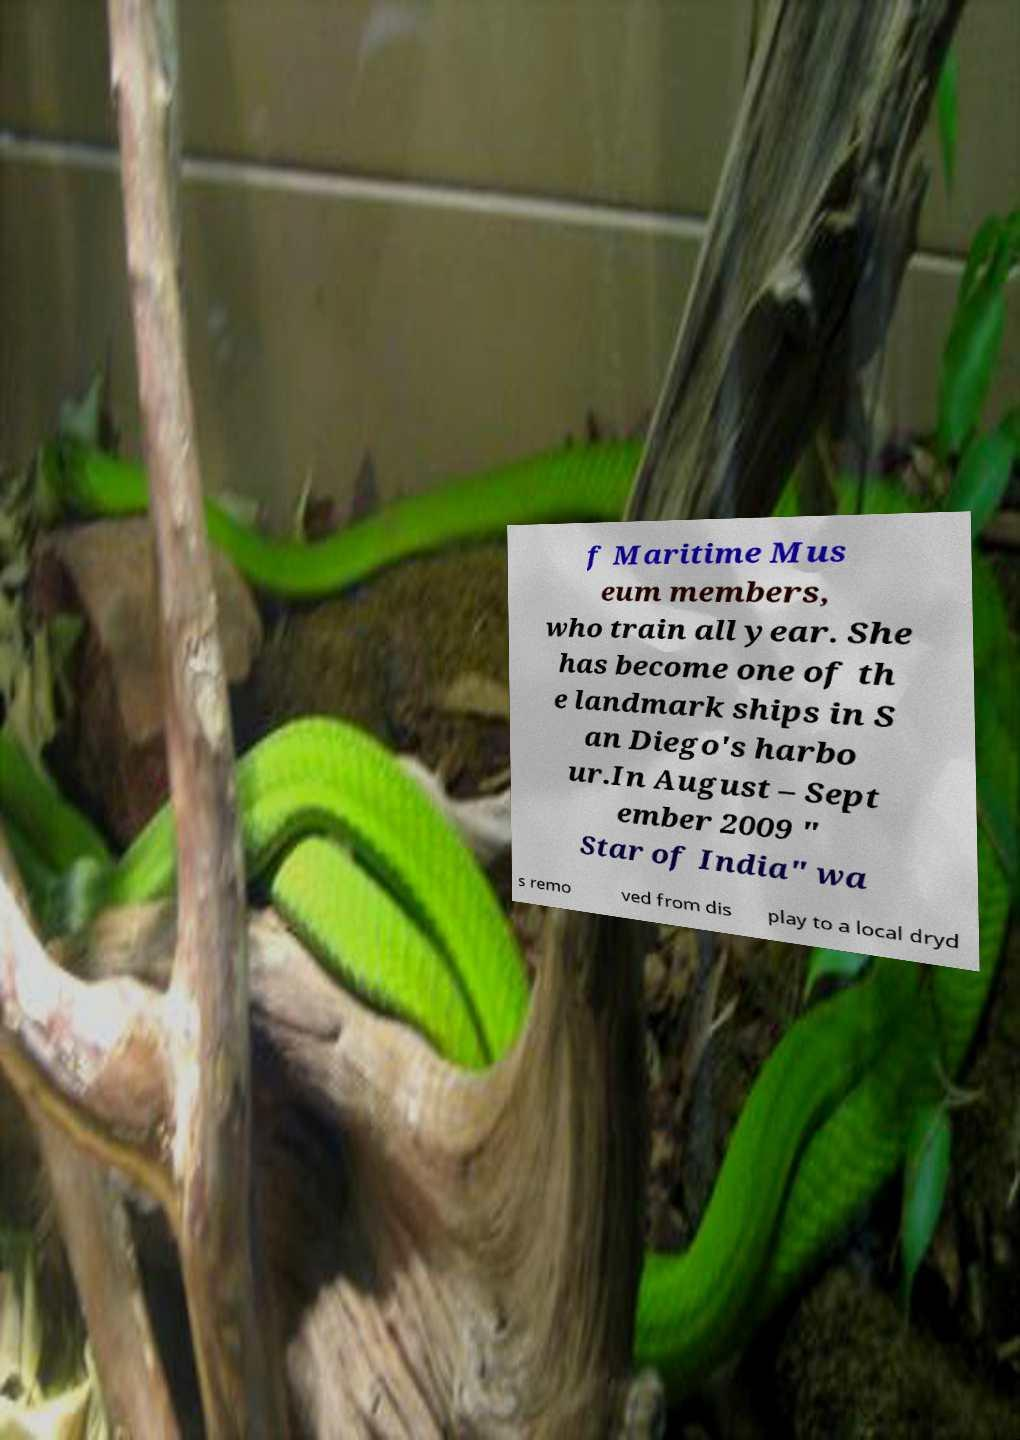Can you accurately transcribe the text from the provided image for me? f Maritime Mus eum members, who train all year. She has become one of th e landmark ships in S an Diego's harbo ur.In August – Sept ember 2009 " Star of India" wa s remo ved from dis play to a local dryd 